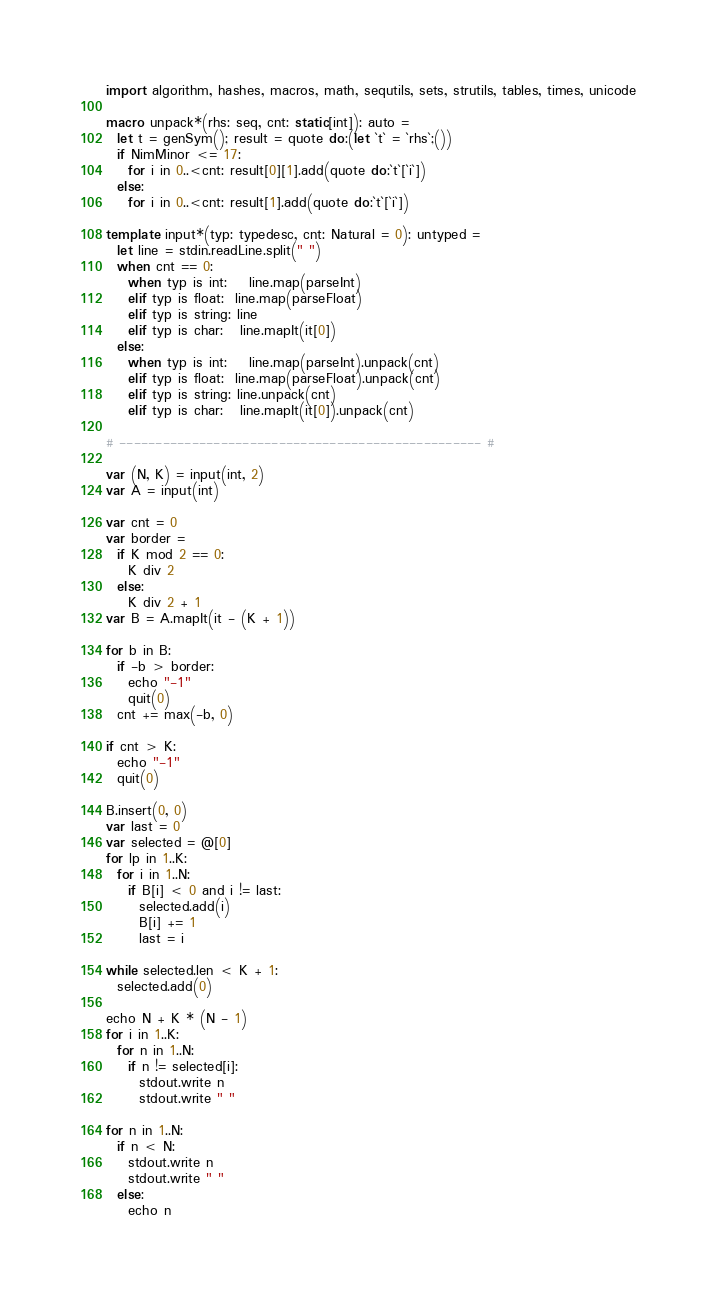Convert code to text. <code><loc_0><loc_0><loc_500><loc_500><_Nim_>import algorithm, hashes, macros, math, sequtils, sets, strutils, tables, times, unicode

macro unpack*(rhs: seq, cnt: static[int]): auto =
  let t = genSym(); result = quote do:(let `t` = `rhs`;())
  if NimMinor <= 17:
    for i in 0..<cnt: result[0][1].add(quote do:`t`[`i`])
  else:
    for i in 0..<cnt: result[1].add(quote do:`t`[`i`])

template input*(typ: typedesc, cnt: Natural = 0): untyped =
  let line = stdin.readLine.split(" ")
  when cnt == 0:
    when typ is int:    line.map(parseInt)
    elif typ is float:  line.map(parseFloat)
    elif typ is string: line
    elif typ is char:   line.mapIt(it[0])
  else:
    when typ is int:    line.map(parseInt).unpack(cnt)
    elif typ is float:  line.map(parseFloat).unpack(cnt)
    elif typ is string: line.unpack(cnt)
    elif typ is char:   line.mapIt(it[0]).unpack(cnt)

# -------------------------------------------------- #

var (N, K) = input(int, 2)
var A = input(int)

var cnt = 0
var border =
  if K mod 2 == 0:
    K div 2
  else:
    K div 2 + 1
var B = A.mapIt(it - (K + 1))

for b in B:
  if -b > border:
    echo "-1"
    quit(0)
  cnt += max(-b, 0)

if cnt > K:
  echo "-1"
  quit(0)

B.insert(0, 0)
var last = 0
var selected = @[0]
for lp in 1..K:
  for i in 1..N:
    if B[i] < 0 and i != last:
      selected.add(i)
      B[i] += 1
      last = i

while selected.len < K + 1:
  selected.add(0)

echo N + K * (N - 1)
for i in 1..K:
  for n in 1..N:
    if n != selected[i]:
      stdout.write n
      stdout.write " "

for n in 1..N:
  if n < N:
    stdout.write n
    stdout.write " "
  else:
    echo n</code> 